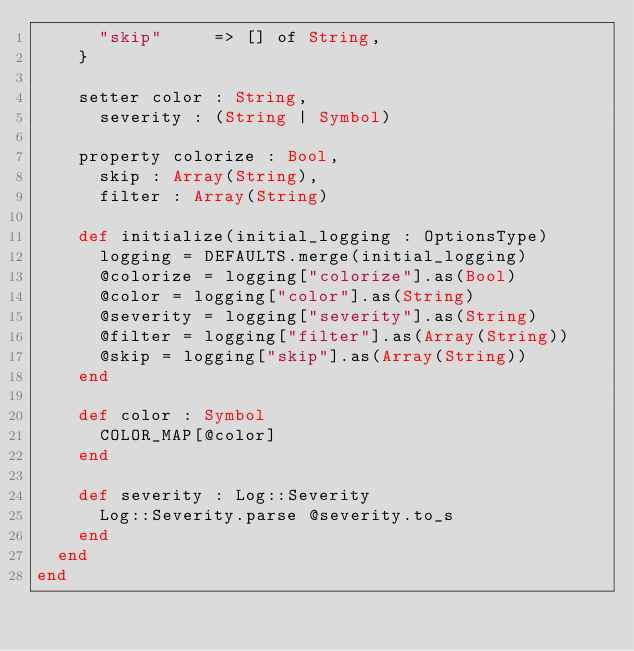Convert code to text. <code><loc_0><loc_0><loc_500><loc_500><_Crystal_>      "skip"     => [] of String,
    }

    setter color : String,
      severity : (String | Symbol)

    property colorize : Bool,
      skip : Array(String),
      filter : Array(String)

    def initialize(initial_logging : OptionsType)
      logging = DEFAULTS.merge(initial_logging)
      @colorize = logging["colorize"].as(Bool)
      @color = logging["color"].as(String)
      @severity = logging["severity"].as(String)
      @filter = logging["filter"].as(Array(String))
      @skip = logging["skip"].as(Array(String))
    end

    def color : Symbol
      COLOR_MAP[@color]
    end

    def severity : Log::Severity
      Log::Severity.parse @severity.to_s
    end
  end
end
</code> 